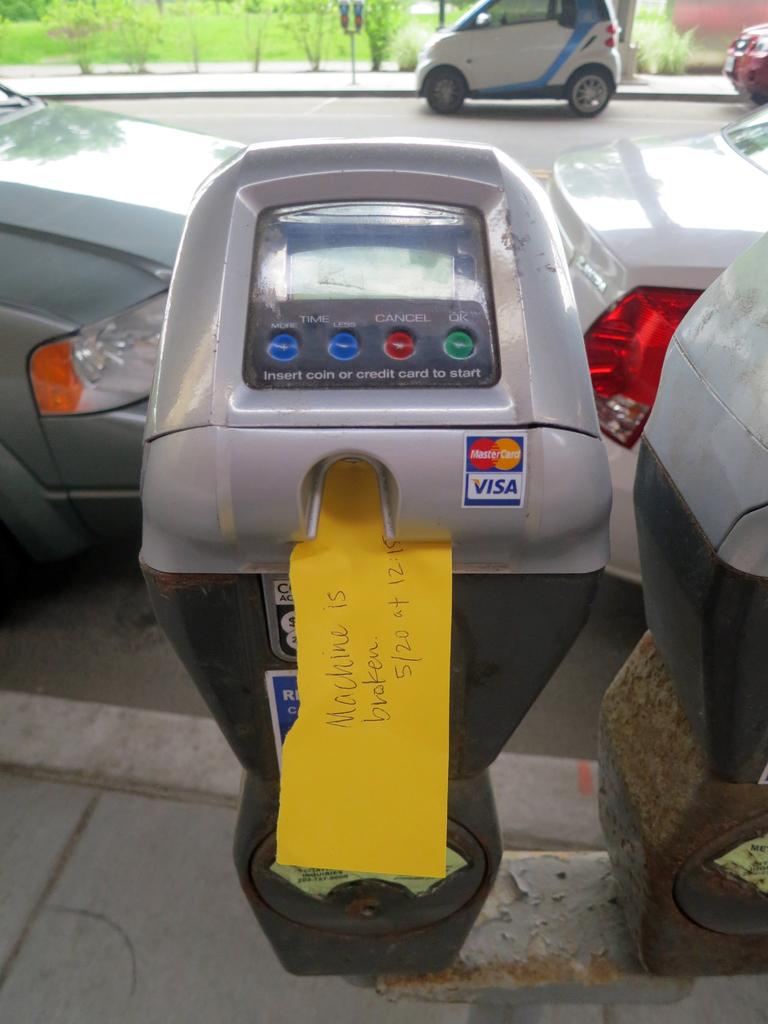<image>
Give a short and clear explanation of the subsequent image. Parking meter machine with yellow handwritten note that Machine is broken 5/20 at 12:15 